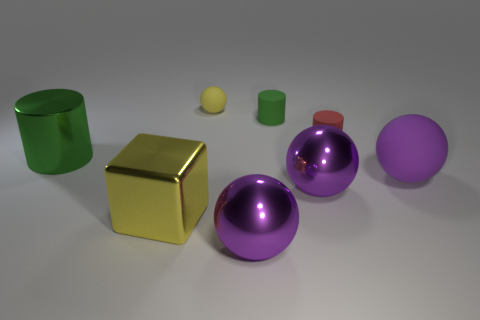Subtract all red cubes. How many purple balls are left? 3 Subtract all purple rubber balls. How many balls are left? 3 Subtract all yellow spheres. How many spheres are left? 3 Subtract all gray spheres. Subtract all purple cylinders. How many spheres are left? 4 Add 1 big gray things. How many objects exist? 9 Subtract 0 purple cubes. How many objects are left? 8 Subtract all blocks. How many objects are left? 7 Subtract all large cyan rubber things. Subtract all red cylinders. How many objects are left? 7 Add 3 yellow balls. How many yellow balls are left? 4 Add 5 tiny brown metal balls. How many tiny brown metal balls exist? 5 